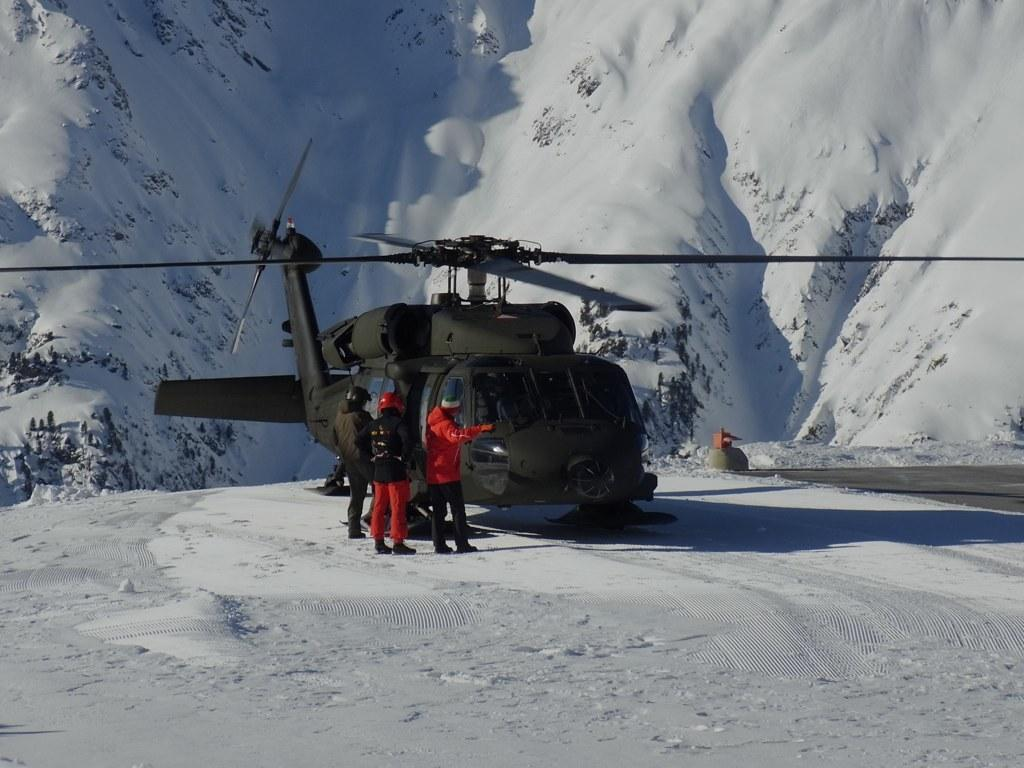What is the main subject in the center of the image? There is a helicopter in the center of the image. Can you describe the people in the image? There are people in the image, but their specific actions or positions are not mentioned in the facts. What can be seen in the background of the image? There is a mountain in the background of the image. What is the condition of the ground at the bottom of the image? There is snow at the bottom of the image. What type of apparatus is being used by the people to alleviate their pain in the image? There is no mention of pain or any apparatus being used by the people in the image. 